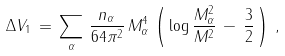<formula> <loc_0><loc_0><loc_500><loc_500>\Delta V _ { 1 } \, = \, \sum _ { \alpha } \, \frac { n _ { \alpha } } { 6 4 \pi ^ { 2 } } \, M _ { \alpha } ^ { 4 } \, \left ( \, \log \frac { M _ { \alpha } ^ { 2 } } { M ^ { 2 } } \, - \, \frac { 3 } { 2 } \, \right ) \, ,</formula> 